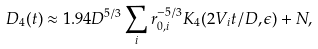Convert formula to latex. <formula><loc_0><loc_0><loc_500><loc_500>D _ { 4 } ( t ) \approx 1 . 9 4 D ^ { 5 / 3 } \sum _ { i } r _ { 0 , i } ^ { - 5 / 3 } K _ { 4 } ( 2 V _ { i } t / D , \epsilon ) + N ,</formula> 